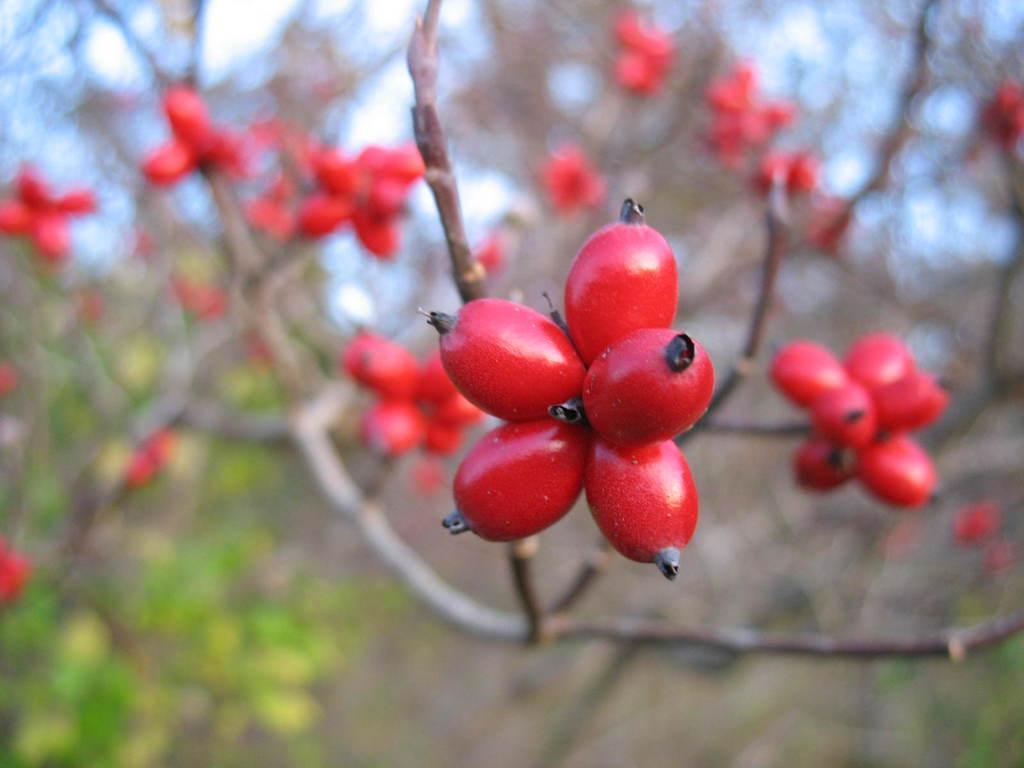Please provide a concise description of this image. In the picture there are rose hip fruits to the branch of a tree and the background of those fruits is blur. 